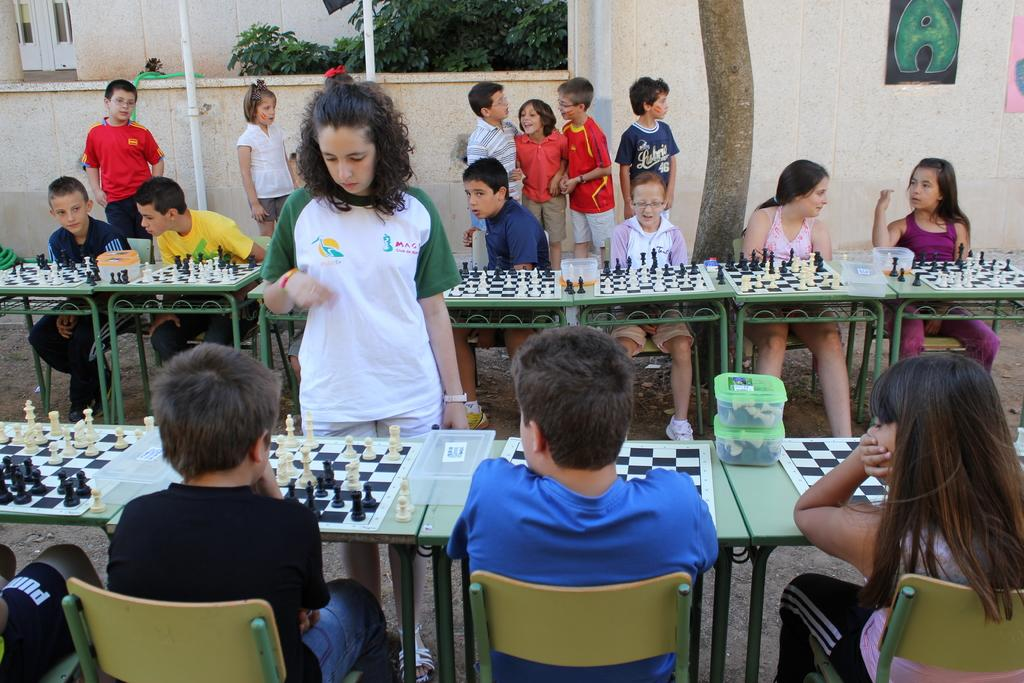What activity is the person in the foreground of the image engaged in? There is a person playing chess in the foreground of the image. Where is the chess game taking place? The chess game is placed on a table. What can be seen in the background of the image? In the background of the image, there are tables, chess boards, persons, boxes, a tree, a wall, and frames. What type of organization is represented by the toad in the image? There is no toad present in the image, so it is not possible to determine any organization related to it. 